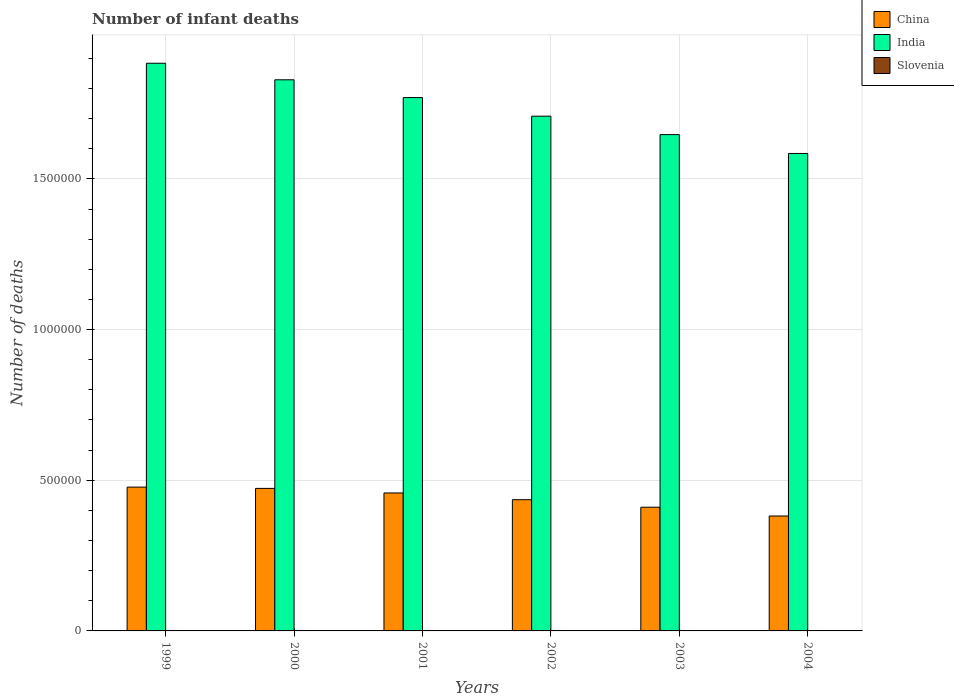How many groups of bars are there?
Your response must be concise. 6. What is the label of the 5th group of bars from the left?
Your answer should be compact. 2003. In how many cases, is the number of bars for a given year not equal to the number of legend labels?
Offer a terse response. 0. What is the number of infant deaths in India in 2001?
Your answer should be compact. 1.77e+06. Across all years, what is the maximum number of infant deaths in China?
Offer a terse response. 4.77e+05. Across all years, what is the minimum number of infant deaths in India?
Your response must be concise. 1.58e+06. In which year was the number of infant deaths in China minimum?
Your answer should be very brief. 2004. What is the total number of infant deaths in India in the graph?
Make the answer very short. 1.04e+07. What is the difference between the number of infant deaths in India in 2001 and that in 2003?
Your response must be concise. 1.23e+05. What is the difference between the number of infant deaths in China in 2002 and the number of infant deaths in Slovenia in 1999?
Keep it short and to the point. 4.35e+05. What is the average number of infant deaths in India per year?
Make the answer very short. 1.74e+06. In the year 2000, what is the difference between the number of infant deaths in Slovenia and number of infant deaths in India?
Ensure brevity in your answer.  -1.83e+06. In how many years, is the number of infant deaths in Slovenia greater than 800000?
Provide a succinct answer. 0. What is the ratio of the number of infant deaths in India in 1999 to that in 2002?
Your response must be concise. 1.1. What is the difference between the highest and the second highest number of infant deaths in India?
Offer a terse response. 5.49e+04. What is the difference between the highest and the lowest number of infant deaths in China?
Your answer should be compact. 9.58e+04. In how many years, is the number of infant deaths in Slovenia greater than the average number of infant deaths in Slovenia taken over all years?
Provide a short and direct response. 3. How many bars are there?
Offer a terse response. 18. How many years are there in the graph?
Offer a terse response. 6. What is the difference between two consecutive major ticks on the Y-axis?
Offer a very short reply. 5.00e+05. Are the values on the major ticks of Y-axis written in scientific E-notation?
Give a very brief answer. No. Does the graph contain any zero values?
Provide a short and direct response. No. Does the graph contain grids?
Provide a short and direct response. Yes. How many legend labels are there?
Your response must be concise. 3. How are the legend labels stacked?
Provide a short and direct response. Vertical. What is the title of the graph?
Your answer should be compact. Number of infant deaths. Does "Kosovo" appear as one of the legend labels in the graph?
Make the answer very short. No. What is the label or title of the X-axis?
Offer a terse response. Years. What is the label or title of the Y-axis?
Offer a terse response. Number of deaths. What is the Number of deaths of China in 1999?
Offer a very short reply. 4.77e+05. What is the Number of deaths in India in 1999?
Give a very brief answer. 1.88e+06. What is the Number of deaths in China in 2000?
Offer a terse response. 4.73e+05. What is the Number of deaths in India in 2000?
Give a very brief answer. 1.83e+06. What is the Number of deaths of China in 2001?
Your response must be concise. 4.58e+05. What is the Number of deaths of India in 2001?
Provide a succinct answer. 1.77e+06. What is the Number of deaths of Slovenia in 2001?
Your response must be concise. 79. What is the Number of deaths in China in 2002?
Keep it short and to the point. 4.36e+05. What is the Number of deaths of India in 2002?
Ensure brevity in your answer.  1.71e+06. What is the Number of deaths in China in 2003?
Keep it short and to the point. 4.11e+05. What is the Number of deaths in India in 2003?
Provide a succinct answer. 1.65e+06. What is the Number of deaths of China in 2004?
Keep it short and to the point. 3.81e+05. What is the Number of deaths in India in 2004?
Your response must be concise. 1.58e+06. What is the Number of deaths of Slovenia in 2004?
Your response must be concise. 64. Across all years, what is the maximum Number of deaths of China?
Keep it short and to the point. 4.77e+05. Across all years, what is the maximum Number of deaths in India?
Provide a short and direct response. 1.88e+06. Across all years, what is the minimum Number of deaths of China?
Offer a terse response. 3.81e+05. Across all years, what is the minimum Number of deaths in India?
Give a very brief answer. 1.58e+06. What is the total Number of deaths of China in the graph?
Provide a succinct answer. 2.64e+06. What is the total Number of deaths in India in the graph?
Make the answer very short. 1.04e+07. What is the total Number of deaths in Slovenia in the graph?
Give a very brief answer. 457. What is the difference between the Number of deaths of China in 1999 and that in 2000?
Your answer should be compact. 4254. What is the difference between the Number of deaths of India in 1999 and that in 2000?
Provide a succinct answer. 5.49e+04. What is the difference between the Number of deaths in China in 1999 and that in 2001?
Your answer should be very brief. 1.94e+04. What is the difference between the Number of deaths of India in 1999 and that in 2001?
Give a very brief answer. 1.14e+05. What is the difference between the Number of deaths of Slovenia in 1999 and that in 2001?
Ensure brevity in your answer.  9. What is the difference between the Number of deaths of China in 1999 and that in 2002?
Your answer should be very brief. 4.17e+04. What is the difference between the Number of deaths in India in 1999 and that in 2002?
Ensure brevity in your answer.  1.76e+05. What is the difference between the Number of deaths of China in 1999 and that in 2003?
Offer a terse response. 6.67e+04. What is the difference between the Number of deaths of India in 1999 and that in 2003?
Make the answer very short. 2.37e+05. What is the difference between the Number of deaths of Slovenia in 1999 and that in 2003?
Offer a very short reply. 19. What is the difference between the Number of deaths in China in 1999 and that in 2004?
Offer a terse response. 9.58e+04. What is the difference between the Number of deaths of India in 1999 and that in 2004?
Ensure brevity in your answer.  2.99e+05. What is the difference between the Number of deaths in Slovenia in 1999 and that in 2004?
Your answer should be compact. 24. What is the difference between the Number of deaths of China in 2000 and that in 2001?
Offer a very short reply. 1.51e+04. What is the difference between the Number of deaths of India in 2000 and that in 2001?
Offer a very short reply. 5.90e+04. What is the difference between the Number of deaths in Slovenia in 2000 and that in 2001?
Keep it short and to the point. 4. What is the difference between the Number of deaths in China in 2000 and that in 2002?
Provide a short and direct response. 3.75e+04. What is the difference between the Number of deaths of India in 2000 and that in 2002?
Make the answer very short. 1.21e+05. What is the difference between the Number of deaths of China in 2000 and that in 2003?
Ensure brevity in your answer.  6.24e+04. What is the difference between the Number of deaths of India in 2000 and that in 2003?
Provide a succinct answer. 1.82e+05. What is the difference between the Number of deaths in China in 2000 and that in 2004?
Give a very brief answer. 9.16e+04. What is the difference between the Number of deaths in India in 2000 and that in 2004?
Your answer should be compact. 2.44e+05. What is the difference between the Number of deaths in China in 2001 and that in 2002?
Keep it short and to the point. 2.23e+04. What is the difference between the Number of deaths in India in 2001 and that in 2002?
Ensure brevity in your answer.  6.18e+04. What is the difference between the Number of deaths in Slovenia in 2001 and that in 2002?
Your answer should be very brief. 5. What is the difference between the Number of deaths in China in 2001 and that in 2003?
Provide a short and direct response. 4.73e+04. What is the difference between the Number of deaths of India in 2001 and that in 2003?
Offer a terse response. 1.23e+05. What is the difference between the Number of deaths of Slovenia in 2001 and that in 2003?
Ensure brevity in your answer.  10. What is the difference between the Number of deaths in China in 2001 and that in 2004?
Your answer should be compact. 7.64e+04. What is the difference between the Number of deaths of India in 2001 and that in 2004?
Your answer should be very brief. 1.86e+05. What is the difference between the Number of deaths in China in 2002 and that in 2003?
Provide a succinct answer. 2.50e+04. What is the difference between the Number of deaths of India in 2002 and that in 2003?
Your response must be concise. 6.11e+04. What is the difference between the Number of deaths in Slovenia in 2002 and that in 2003?
Offer a very short reply. 5. What is the difference between the Number of deaths of China in 2002 and that in 2004?
Provide a short and direct response. 5.41e+04. What is the difference between the Number of deaths in India in 2002 and that in 2004?
Offer a very short reply. 1.24e+05. What is the difference between the Number of deaths of China in 2003 and that in 2004?
Make the answer very short. 2.91e+04. What is the difference between the Number of deaths in India in 2003 and that in 2004?
Provide a short and direct response. 6.26e+04. What is the difference between the Number of deaths of China in 1999 and the Number of deaths of India in 2000?
Your response must be concise. -1.35e+06. What is the difference between the Number of deaths in China in 1999 and the Number of deaths in Slovenia in 2000?
Offer a terse response. 4.77e+05. What is the difference between the Number of deaths in India in 1999 and the Number of deaths in Slovenia in 2000?
Your response must be concise. 1.88e+06. What is the difference between the Number of deaths of China in 1999 and the Number of deaths of India in 2001?
Offer a very short reply. -1.29e+06. What is the difference between the Number of deaths in China in 1999 and the Number of deaths in Slovenia in 2001?
Ensure brevity in your answer.  4.77e+05. What is the difference between the Number of deaths in India in 1999 and the Number of deaths in Slovenia in 2001?
Your response must be concise. 1.88e+06. What is the difference between the Number of deaths of China in 1999 and the Number of deaths of India in 2002?
Your answer should be very brief. -1.23e+06. What is the difference between the Number of deaths in China in 1999 and the Number of deaths in Slovenia in 2002?
Your answer should be very brief. 4.77e+05. What is the difference between the Number of deaths of India in 1999 and the Number of deaths of Slovenia in 2002?
Give a very brief answer. 1.88e+06. What is the difference between the Number of deaths in China in 1999 and the Number of deaths in India in 2003?
Your answer should be compact. -1.17e+06. What is the difference between the Number of deaths in China in 1999 and the Number of deaths in Slovenia in 2003?
Keep it short and to the point. 4.77e+05. What is the difference between the Number of deaths of India in 1999 and the Number of deaths of Slovenia in 2003?
Provide a short and direct response. 1.88e+06. What is the difference between the Number of deaths of China in 1999 and the Number of deaths of India in 2004?
Provide a succinct answer. -1.11e+06. What is the difference between the Number of deaths of China in 1999 and the Number of deaths of Slovenia in 2004?
Make the answer very short. 4.77e+05. What is the difference between the Number of deaths in India in 1999 and the Number of deaths in Slovenia in 2004?
Your answer should be compact. 1.88e+06. What is the difference between the Number of deaths of China in 2000 and the Number of deaths of India in 2001?
Your answer should be compact. -1.30e+06. What is the difference between the Number of deaths of China in 2000 and the Number of deaths of Slovenia in 2001?
Your answer should be very brief. 4.73e+05. What is the difference between the Number of deaths of India in 2000 and the Number of deaths of Slovenia in 2001?
Ensure brevity in your answer.  1.83e+06. What is the difference between the Number of deaths in China in 2000 and the Number of deaths in India in 2002?
Give a very brief answer. -1.24e+06. What is the difference between the Number of deaths of China in 2000 and the Number of deaths of Slovenia in 2002?
Make the answer very short. 4.73e+05. What is the difference between the Number of deaths in India in 2000 and the Number of deaths in Slovenia in 2002?
Your answer should be compact. 1.83e+06. What is the difference between the Number of deaths in China in 2000 and the Number of deaths in India in 2003?
Your response must be concise. -1.17e+06. What is the difference between the Number of deaths in China in 2000 and the Number of deaths in Slovenia in 2003?
Make the answer very short. 4.73e+05. What is the difference between the Number of deaths of India in 2000 and the Number of deaths of Slovenia in 2003?
Give a very brief answer. 1.83e+06. What is the difference between the Number of deaths in China in 2000 and the Number of deaths in India in 2004?
Your answer should be compact. -1.11e+06. What is the difference between the Number of deaths of China in 2000 and the Number of deaths of Slovenia in 2004?
Your answer should be very brief. 4.73e+05. What is the difference between the Number of deaths of India in 2000 and the Number of deaths of Slovenia in 2004?
Make the answer very short. 1.83e+06. What is the difference between the Number of deaths in China in 2001 and the Number of deaths in India in 2002?
Your response must be concise. -1.25e+06. What is the difference between the Number of deaths of China in 2001 and the Number of deaths of Slovenia in 2002?
Offer a very short reply. 4.58e+05. What is the difference between the Number of deaths in India in 2001 and the Number of deaths in Slovenia in 2002?
Provide a short and direct response. 1.77e+06. What is the difference between the Number of deaths in China in 2001 and the Number of deaths in India in 2003?
Keep it short and to the point. -1.19e+06. What is the difference between the Number of deaths in China in 2001 and the Number of deaths in Slovenia in 2003?
Ensure brevity in your answer.  4.58e+05. What is the difference between the Number of deaths of India in 2001 and the Number of deaths of Slovenia in 2003?
Offer a very short reply. 1.77e+06. What is the difference between the Number of deaths of China in 2001 and the Number of deaths of India in 2004?
Ensure brevity in your answer.  -1.13e+06. What is the difference between the Number of deaths of China in 2001 and the Number of deaths of Slovenia in 2004?
Offer a terse response. 4.58e+05. What is the difference between the Number of deaths of India in 2001 and the Number of deaths of Slovenia in 2004?
Give a very brief answer. 1.77e+06. What is the difference between the Number of deaths of China in 2002 and the Number of deaths of India in 2003?
Your answer should be very brief. -1.21e+06. What is the difference between the Number of deaths of China in 2002 and the Number of deaths of Slovenia in 2003?
Ensure brevity in your answer.  4.35e+05. What is the difference between the Number of deaths of India in 2002 and the Number of deaths of Slovenia in 2003?
Give a very brief answer. 1.71e+06. What is the difference between the Number of deaths in China in 2002 and the Number of deaths in India in 2004?
Keep it short and to the point. -1.15e+06. What is the difference between the Number of deaths in China in 2002 and the Number of deaths in Slovenia in 2004?
Provide a succinct answer. 4.35e+05. What is the difference between the Number of deaths of India in 2002 and the Number of deaths of Slovenia in 2004?
Provide a succinct answer. 1.71e+06. What is the difference between the Number of deaths in China in 2003 and the Number of deaths in India in 2004?
Provide a short and direct response. -1.17e+06. What is the difference between the Number of deaths in China in 2003 and the Number of deaths in Slovenia in 2004?
Your answer should be very brief. 4.10e+05. What is the difference between the Number of deaths in India in 2003 and the Number of deaths in Slovenia in 2004?
Ensure brevity in your answer.  1.65e+06. What is the average Number of deaths of China per year?
Offer a terse response. 4.39e+05. What is the average Number of deaths in India per year?
Ensure brevity in your answer.  1.74e+06. What is the average Number of deaths in Slovenia per year?
Your answer should be very brief. 76.17. In the year 1999, what is the difference between the Number of deaths of China and Number of deaths of India?
Your response must be concise. -1.41e+06. In the year 1999, what is the difference between the Number of deaths of China and Number of deaths of Slovenia?
Your answer should be compact. 4.77e+05. In the year 1999, what is the difference between the Number of deaths in India and Number of deaths in Slovenia?
Provide a short and direct response. 1.88e+06. In the year 2000, what is the difference between the Number of deaths of China and Number of deaths of India?
Make the answer very short. -1.36e+06. In the year 2000, what is the difference between the Number of deaths in China and Number of deaths in Slovenia?
Provide a short and direct response. 4.73e+05. In the year 2000, what is the difference between the Number of deaths of India and Number of deaths of Slovenia?
Give a very brief answer. 1.83e+06. In the year 2001, what is the difference between the Number of deaths in China and Number of deaths in India?
Give a very brief answer. -1.31e+06. In the year 2001, what is the difference between the Number of deaths in China and Number of deaths in Slovenia?
Offer a terse response. 4.58e+05. In the year 2001, what is the difference between the Number of deaths of India and Number of deaths of Slovenia?
Your response must be concise. 1.77e+06. In the year 2002, what is the difference between the Number of deaths of China and Number of deaths of India?
Provide a succinct answer. -1.27e+06. In the year 2002, what is the difference between the Number of deaths of China and Number of deaths of Slovenia?
Your response must be concise. 4.35e+05. In the year 2002, what is the difference between the Number of deaths in India and Number of deaths in Slovenia?
Give a very brief answer. 1.71e+06. In the year 2003, what is the difference between the Number of deaths in China and Number of deaths in India?
Give a very brief answer. -1.24e+06. In the year 2003, what is the difference between the Number of deaths in China and Number of deaths in Slovenia?
Keep it short and to the point. 4.10e+05. In the year 2003, what is the difference between the Number of deaths in India and Number of deaths in Slovenia?
Keep it short and to the point. 1.65e+06. In the year 2004, what is the difference between the Number of deaths in China and Number of deaths in India?
Give a very brief answer. -1.20e+06. In the year 2004, what is the difference between the Number of deaths of China and Number of deaths of Slovenia?
Your answer should be compact. 3.81e+05. In the year 2004, what is the difference between the Number of deaths in India and Number of deaths in Slovenia?
Your response must be concise. 1.58e+06. What is the ratio of the Number of deaths of Slovenia in 1999 to that in 2000?
Keep it short and to the point. 1.06. What is the ratio of the Number of deaths in China in 1999 to that in 2001?
Keep it short and to the point. 1.04. What is the ratio of the Number of deaths in India in 1999 to that in 2001?
Offer a very short reply. 1.06. What is the ratio of the Number of deaths in Slovenia in 1999 to that in 2001?
Your response must be concise. 1.11. What is the ratio of the Number of deaths in China in 1999 to that in 2002?
Give a very brief answer. 1.1. What is the ratio of the Number of deaths of India in 1999 to that in 2002?
Your response must be concise. 1.1. What is the ratio of the Number of deaths of Slovenia in 1999 to that in 2002?
Offer a very short reply. 1.19. What is the ratio of the Number of deaths in China in 1999 to that in 2003?
Make the answer very short. 1.16. What is the ratio of the Number of deaths in India in 1999 to that in 2003?
Your answer should be very brief. 1.14. What is the ratio of the Number of deaths of Slovenia in 1999 to that in 2003?
Keep it short and to the point. 1.28. What is the ratio of the Number of deaths of China in 1999 to that in 2004?
Offer a very short reply. 1.25. What is the ratio of the Number of deaths of India in 1999 to that in 2004?
Provide a succinct answer. 1.19. What is the ratio of the Number of deaths in Slovenia in 1999 to that in 2004?
Make the answer very short. 1.38. What is the ratio of the Number of deaths of China in 2000 to that in 2001?
Your answer should be compact. 1.03. What is the ratio of the Number of deaths of India in 2000 to that in 2001?
Your answer should be compact. 1.03. What is the ratio of the Number of deaths in Slovenia in 2000 to that in 2001?
Make the answer very short. 1.05. What is the ratio of the Number of deaths in China in 2000 to that in 2002?
Your answer should be compact. 1.09. What is the ratio of the Number of deaths in India in 2000 to that in 2002?
Keep it short and to the point. 1.07. What is the ratio of the Number of deaths of Slovenia in 2000 to that in 2002?
Your answer should be very brief. 1.12. What is the ratio of the Number of deaths in China in 2000 to that in 2003?
Offer a very short reply. 1.15. What is the ratio of the Number of deaths in India in 2000 to that in 2003?
Your answer should be compact. 1.11. What is the ratio of the Number of deaths of Slovenia in 2000 to that in 2003?
Your answer should be compact. 1.2. What is the ratio of the Number of deaths of China in 2000 to that in 2004?
Give a very brief answer. 1.24. What is the ratio of the Number of deaths in India in 2000 to that in 2004?
Your answer should be very brief. 1.15. What is the ratio of the Number of deaths of Slovenia in 2000 to that in 2004?
Your answer should be compact. 1.3. What is the ratio of the Number of deaths of China in 2001 to that in 2002?
Offer a terse response. 1.05. What is the ratio of the Number of deaths of India in 2001 to that in 2002?
Provide a short and direct response. 1.04. What is the ratio of the Number of deaths of Slovenia in 2001 to that in 2002?
Your response must be concise. 1.07. What is the ratio of the Number of deaths in China in 2001 to that in 2003?
Provide a succinct answer. 1.12. What is the ratio of the Number of deaths in India in 2001 to that in 2003?
Make the answer very short. 1.07. What is the ratio of the Number of deaths of Slovenia in 2001 to that in 2003?
Give a very brief answer. 1.14. What is the ratio of the Number of deaths of China in 2001 to that in 2004?
Give a very brief answer. 1.2. What is the ratio of the Number of deaths of India in 2001 to that in 2004?
Ensure brevity in your answer.  1.12. What is the ratio of the Number of deaths of Slovenia in 2001 to that in 2004?
Offer a terse response. 1.23. What is the ratio of the Number of deaths of China in 2002 to that in 2003?
Provide a short and direct response. 1.06. What is the ratio of the Number of deaths of India in 2002 to that in 2003?
Your answer should be compact. 1.04. What is the ratio of the Number of deaths of Slovenia in 2002 to that in 2003?
Ensure brevity in your answer.  1.07. What is the ratio of the Number of deaths in China in 2002 to that in 2004?
Give a very brief answer. 1.14. What is the ratio of the Number of deaths in India in 2002 to that in 2004?
Your response must be concise. 1.08. What is the ratio of the Number of deaths in Slovenia in 2002 to that in 2004?
Your answer should be compact. 1.16. What is the ratio of the Number of deaths of China in 2003 to that in 2004?
Provide a short and direct response. 1.08. What is the ratio of the Number of deaths of India in 2003 to that in 2004?
Make the answer very short. 1.04. What is the ratio of the Number of deaths in Slovenia in 2003 to that in 2004?
Your response must be concise. 1.08. What is the difference between the highest and the second highest Number of deaths in China?
Make the answer very short. 4254. What is the difference between the highest and the second highest Number of deaths in India?
Give a very brief answer. 5.49e+04. What is the difference between the highest and the second highest Number of deaths in Slovenia?
Keep it short and to the point. 5. What is the difference between the highest and the lowest Number of deaths of China?
Offer a terse response. 9.58e+04. What is the difference between the highest and the lowest Number of deaths in India?
Your response must be concise. 2.99e+05. What is the difference between the highest and the lowest Number of deaths of Slovenia?
Give a very brief answer. 24. 